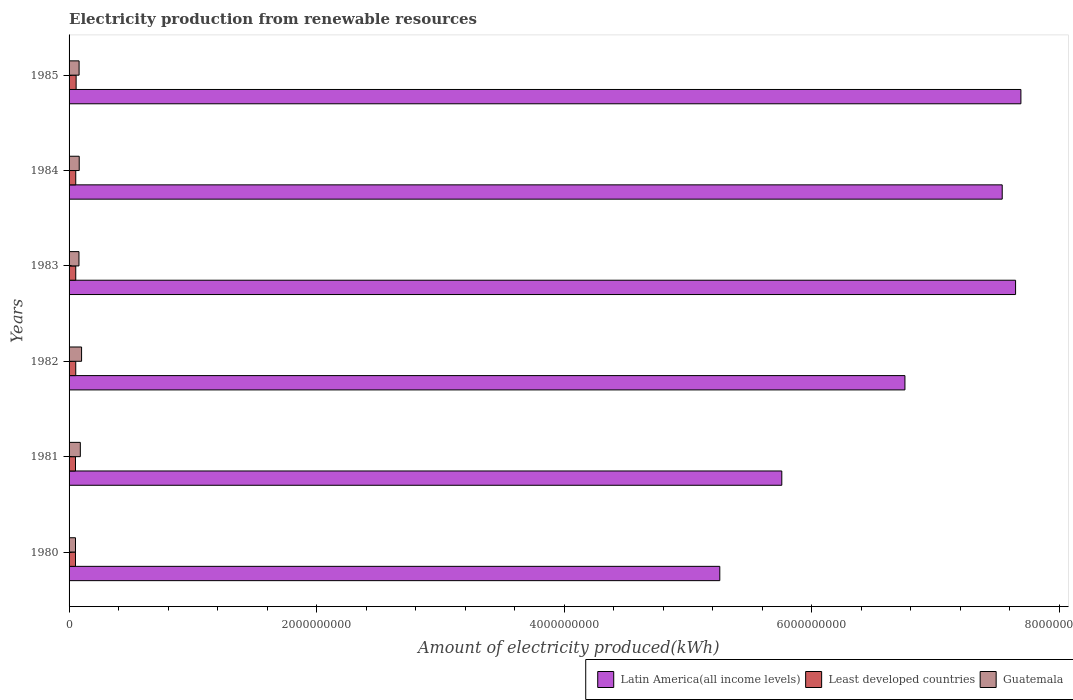How many groups of bars are there?
Your response must be concise. 6. Are the number of bars per tick equal to the number of legend labels?
Your answer should be compact. Yes. Are the number of bars on each tick of the Y-axis equal?
Your response must be concise. Yes. What is the amount of electricity produced in Guatemala in 1980?
Offer a very short reply. 5.20e+07. Across all years, what is the maximum amount of electricity produced in Latin America(all income levels)?
Provide a short and direct response. 7.69e+09. Across all years, what is the minimum amount of electricity produced in Least developed countries?
Your response must be concise. 5.20e+07. In which year was the amount of electricity produced in Guatemala maximum?
Ensure brevity in your answer.  1982. In which year was the amount of electricity produced in Latin America(all income levels) minimum?
Your answer should be compact. 1980. What is the total amount of electricity produced in Guatemala in the graph?
Offer a terse response. 4.87e+08. What is the difference between the amount of electricity produced in Latin America(all income levels) in 1982 and that in 1983?
Your answer should be very brief. -8.94e+08. What is the difference between the amount of electricity produced in Guatemala in 1983 and the amount of electricity produced in Latin America(all income levels) in 1984?
Offer a terse response. -7.46e+09. What is the average amount of electricity produced in Latin America(all income levels) per year?
Provide a short and direct response. 6.78e+09. What is the ratio of the amount of electricity produced in Latin America(all income levels) in 1980 to that in 1982?
Provide a short and direct response. 0.78. What is the difference between the highest and the second highest amount of electricity produced in Latin America(all income levels)?
Your answer should be very brief. 4.30e+07. What is the difference between the highest and the lowest amount of electricity produced in Least developed countries?
Offer a very short reply. 5.00e+06. In how many years, is the amount of electricity produced in Latin America(all income levels) greater than the average amount of electricity produced in Latin America(all income levels) taken over all years?
Give a very brief answer. 3. Is the sum of the amount of electricity produced in Guatemala in 1981 and 1984 greater than the maximum amount of electricity produced in Least developed countries across all years?
Your response must be concise. Yes. What does the 3rd bar from the top in 1982 represents?
Give a very brief answer. Latin America(all income levels). What does the 3rd bar from the bottom in 1985 represents?
Your response must be concise. Guatemala. Is it the case that in every year, the sum of the amount of electricity produced in Guatemala and amount of electricity produced in Latin America(all income levels) is greater than the amount of electricity produced in Least developed countries?
Provide a short and direct response. Yes. How many bars are there?
Ensure brevity in your answer.  18. Are all the bars in the graph horizontal?
Provide a short and direct response. Yes. What is the difference between two consecutive major ticks on the X-axis?
Your response must be concise. 2.00e+09. Are the values on the major ticks of X-axis written in scientific E-notation?
Offer a terse response. No. Where does the legend appear in the graph?
Ensure brevity in your answer.  Bottom right. How are the legend labels stacked?
Provide a succinct answer. Horizontal. What is the title of the graph?
Offer a very short reply. Electricity production from renewable resources. Does "Kazakhstan" appear as one of the legend labels in the graph?
Offer a very short reply. No. What is the label or title of the X-axis?
Provide a short and direct response. Amount of electricity produced(kWh). What is the label or title of the Y-axis?
Your response must be concise. Years. What is the Amount of electricity produced(kWh) in Latin America(all income levels) in 1980?
Your answer should be compact. 5.26e+09. What is the Amount of electricity produced(kWh) in Least developed countries in 1980?
Offer a very short reply. 5.20e+07. What is the Amount of electricity produced(kWh) of Guatemala in 1980?
Your answer should be compact. 5.20e+07. What is the Amount of electricity produced(kWh) of Latin America(all income levels) in 1981?
Keep it short and to the point. 5.76e+09. What is the Amount of electricity produced(kWh) of Least developed countries in 1981?
Give a very brief answer. 5.20e+07. What is the Amount of electricity produced(kWh) in Guatemala in 1981?
Provide a succinct answer. 9.10e+07. What is the Amount of electricity produced(kWh) of Latin America(all income levels) in 1982?
Your answer should be compact. 6.75e+09. What is the Amount of electricity produced(kWh) in Least developed countries in 1982?
Offer a very short reply. 5.40e+07. What is the Amount of electricity produced(kWh) of Guatemala in 1982?
Your response must be concise. 1.01e+08. What is the Amount of electricity produced(kWh) of Latin America(all income levels) in 1983?
Your answer should be compact. 7.65e+09. What is the Amount of electricity produced(kWh) in Least developed countries in 1983?
Offer a very short reply. 5.40e+07. What is the Amount of electricity produced(kWh) in Guatemala in 1983?
Give a very brief answer. 8.00e+07. What is the Amount of electricity produced(kWh) in Latin America(all income levels) in 1984?
Keep it short and to the point. 7.54e+09. What is the Amount of electricity produced(kWh) in Least developed countries in 1984?
Offer a very short reply. 5.40e+07. What is the Amount of electricity produced(kWh) of Guatemala in 1984?
Offer a terse response. 8.20e+07. What is the Amount of electricity produced(kWh) in Latin America(all income levels) in 1985?
Ensure brevity in your answer.  7.69e+09. What is the Amount of electricity produced(kWh) of Least developed countries in 1985?
Offer a terse response. 5.70e+07. What is the Amount of electricity produced(kWh) in Guatemala in 1985?
Give a very brief answer. 8.10e+07. Across all years, what is the maximum Amount of electricity produced(kWh) of Latin America(all income levels)?
Ensure brevity in your answer.  7.69e+09. Across all years, what is the maximum Amount of electricity produced(kWh) of Least developed countries?
Your answer should be very brief. 5.70e+07. Across all years, what is the maximum Amount of electricity produced(kWh) of Guatemala?
Give a very brief answer. 1.01e+08. Across all years, what is the minimum Amount of electricity produced(kWh) of Latin America(all income levels)?
Give a very brief answer. 5.26e+09. Across all years, what is the minimum Amount of electricity produced(kWh) in Least developed countries?
Make the answer very short. 5.20e+07. Across all years, what is the minimum Amount of electricity produced(kWh) of Guatemala?
Provide a short and direct response. 5.20e+07. What is the total Amount of electricity produced(kWh) in Latin America(all income levels) in the graph?
Provide a short and direct response. 4.06e+1. What is the total Amount of electricity produced(kWh) in Least developed countries in the graph?
Provide a succinct answer. 3.23e+08. What is the total Amount of electricity produced(kWh) of Guatemala in the graph?
Ensure brevity in your answer.  4.87e+08. What is the difference between the Amount of electricity produced(kWh) in Latin America(all income levels) in 1980 and that in 1981?
Provide a succinct answer. -5.01e+08. What is the difference between the Amount of electricity produced(kWh) in Least developed countries in 1980 and that in 1981?
Ensure brevity in your answer.  0. What is the difference between the Amount of electricity produced(kWh) in Guatemala in 1980 and that in 1981?
Make the answer very short. -3.90e+07. What is the difference between the Amount of electricity produced(kWh) in Latin America(all income levels) in 1980 and that in 1982?
Your response must be concise. -1.50e+09. What is the difference between the Amount of electricity produced(kWh) of Least developed countries in 1980 and that in 1982?
Your answer should be compact. -2.00e+06. What is the difference between the Amount of electricity produced(kWh) in Guatemala in 1980 and that in 1982?
Provide a short and direct response. -4.90e+07. What is the difference between the Amount of electricity produced(kWh) of Latin America(all income levels) in 1980 and that in 1983?
Keep it short and to the point. -2.39e+09. What is the difference between the Amount of electricity produced(kWh) in Guatemala in 1980 and that in 1983?
Make the answer very short. -2.80e+07. What is the difference between the Amount of electricity produced(kWh) of Latin America(all income levels) in 1980 and that in 1984?
Provide a succinct answer. -2.28e+09. What is the difference between the Amount of electricity produced(kWh) in Guatemala in 1980 and that in 1984?
Provide a succinct answer. -3.00e+07. What is the difference between the Amount of electricity produced(kWh) of Latin America(all income levels) in 1980 and that in 1985?
Make the answer very short. -2.43e+09. What is the difference between the Amount of electricity produced(kWh) of Least developed countries in 1980 and that in 1985?
Your response must be concise. -5.00e+06. What is the difference between the Amount of electricity produced(kWh) in Guatemala in 1980 and that in 1985?
Make the answer very short. -2.90e+07. What is the difference between the Amount of electricity produced(kWh) in Latin America(all income levels) in 1981 and that in 1982?
Your response must be concise. -9.95e+08. What is the difference between the Amount of electricity produced(kWh) in Least developed countries in 1981 and that in 1982?
Keep it short and to the point. -2.00e+06. What is the difference between the Amount of electricity produced(kWh) in Guatemala in 1981 and that in 1982?
Your answer should be very brief. -1.00e+07. What is the difference between the Amount of electricity produced(kWh) of Latin America(all income levels) in 1981 and that in 1983?
Keep it short and to the point. -1.89e+09. What is the difference between the Amount of electricity produced(kWh) in Least developed countries in 1981 and that in 1983?
Your answer should be compact. -2.00e+06. What is the difference between the Amount of electricity produced(kWh) in Guatemala in 1981 and that in 1983?
Ensure brevity in your answer.  1.10e+07. What is the difference between the Amount of electricity produced(kWh) in Latin America(all income levels) in 1981 and that in 1984?
Keep it short and to the point. -1.78e+09. What is the difference between the Amount of electricity produced(kWh) of Least developed countries in 1981 and that in 1984?
Your answer should be compact. -2.00e+06. What is the difference between the Amount of electricity produced(kWh) of Guatemala in 1981 and that in 1984?
Offer a very short reply. 9.00e+06. What is the difference between the Amount of electricity produced(kWh) of Latin America(all income levels) in 1981 and that in 1985?
Ensure brevity in your answer.  -1.93e+09. What is the difference between the Amount of electricity produced(kWh) of Least developed countries in 1981 and that in 1985?
Your response must be concise. -5.00e+06. What is the difference between the Amount of electricity produced(kWh) of Guatemala in 1981 and that in 1985?
Offer a very short reply. 1.00e+07. What is the difference between the Amount of electricity produced(kWh) of Latin America(all income levels) in 1982 and that in 1983?
Offer a terse response. -8.94e+08. What is the difference between the Amount of electricity produced(kWh) of Least developed countries in 1982 and that in 1983?
Keep it short and to the point. 0. What is the difference between the Amount of electricity produced(kWh) of Guatemala in 1982 and that in 1983?
Offer a very short reply. 2.10e+07. What is the difference between the Amount of electricity produced(kWh) in Latin America(all income levels) in 1982 and that in 1984?
Offer a terse response. -7.86e+08. What is the difference between the Amount of electricity produced(kWh) of Guatemala in 1982 and that in 1984?
Provide a succinct answer. 1.90e+07. What is the difference between the Amount of electricity produced(kWh) of Latin America(all income levels) in 1982 and that in 1985?
Keep it short and to the point. -9.37e+08. What is the difference between the Amount of electricity produced(kWh) in Least developed countries in 1982 and that in 1985?
Keep it short and to the point. -3.00e+06. What is the difference between the Amount of electricity produced(kWh) of Guatemala in 1982 and that in 1985?
Provide a short and direct response. 2.00e+07. What is the difference between the Amount of electricity produced(kWh) in Latin America(all income levels) in 1983 and that in 1984?
Your answer should be compact. 1.08e+08. What is the difference between the Amount of electricity produced(kWh) in Guatemala in 1983 and that in 1984?
Provide a succinct answer. -2.00e+06. What is the difference between the Amount of electricity produced(kWh) in Latin America(all income levels) in 1983 and that in 1985?
Provide a short and direct response. -4.30e+07. What is the difference between the Amount of electricity produced(kWh) in Guatemala in 1983 and that in 1985?
Keep it short and to the point. -1.00e+06. What is the difference between the Amount of electricity produced(kWh) of Latin America(all income levels) in 1984 and that in 1985?
Offer a terse response. -1.51e+08. What is the difference between the Amount of electricity produced(kWh) of Latin America(all income levels) in 1980 and the Amount of electricity produced(kWh) of Least developed countries in 1981?
Make the answer very short. 5.21e+09. What is the difference between the Amount of electricity produced(kWh) in Latin America(all income levels) in 1980 and the Amount of electricity produced(kWh) in Guatemala in 1981?
Ensure brevity in your answer.  5.17e+09. What is the difference between the Amount of electricity produced(kWh) in Least developed countries in 1980 and the Amount of electricity produced(kWh) in Guatemala in 1981?
Ensure brevity in your answer.  -3.90e+07. What is the difference between the Amount of electricity produced(kWh) in Latin America(all income levels) in 1980 and the Amount of electricity produced(kWh) in Least developed countries in 1982?
Offer a very short reply. 5.20e+09. What is the difference between the Amount of electricity produced(kWh) of Latin America(all income levels) in 1980 and the Amount of electricity produced(kWh) of Guatemala in 1982?
Your answer should be very brief. 5.16e+09. What is the difference between the Amount of electricity produced(kWh) of Least developed countries in 1980 and the Amount of electricity produced(kWh) of Guatemala in 1982?
Give a very brief answer. -4.90e+07. What is the difference between the Amount of electricity produced(kWh) of Latin America(all income levels) in 1980 and the Amount of electricity produced(kWh) of Least developed countries in 1983?
Give a very brief answer. 5.20e+09. What is the difference between the Amount of electricity produced(kWh) of Latin America(all income levels) in 1980 and the Amount of electricity produced(kWh) of Guatemala in 1983?
Make the answer very short. 5.18e+09. What is the difference between the Amount of electricity produced(kWh) of Least developed countries in 1980 and the Amount of electricity produced(kWh) of Guatemala in 1983?
Offer a very short reply. -2.80e+07. What is the difference between the Amount of electricity produced(kWh) of Latin America(all income levels) in 1980 and the Amount of electricity produced(kWh) of Least developed countries in 1984?
Offer a terse response. 5.20e+09. What is the difference between the Amount of electricity produced(kWh) in Latin America(all income levels) in 1980 and the Amount of electricity produced(kWh) in Guatemala in 1984?
Provide a succinct answer. 5.18e+09. What is the difference between the Amount of electricity produced(kWh) of Least developed countries in 1980 and the Amount of electricity produced(kWh) of Guatemala in 1984?
Your response must be concise. -3.00e+07. What is the difference between the Amount of electricity produced(kWh) of Latin America(all income levels) in 1980 and the Amount of electricity produced(kWh) of Least developed countries in 1985?
Offer a very short reply. 5.20e+09. What is the difference between the Amount of electricity produced(kWh) in Latin America(all income levels) in 1980 and the Amount of electricity produced(kWh) in Guatemala in 1985?
Provide a succinct answer. 5.18e+09. What is the difference between the Amount of electricity produced(kWh) in Least developed countries in 1980 and the Amount of electricity produced(kWh) in Guatemala in 1985?
Your answer should be compact. -2.90e+07. What is the difference between the Amount of electricity produced(kWh) of Latin America(all income levels) in 1981 and the Amount of electricity produced(kWh) of Least developed countries in 1982?
Provide a short and direct response. 5.70e+09. What is the difference between the Amount of electricity produced(kWh) in Latin America(all income levels) in 1981 and the Amount of electricity produced(kWh) in Guatemala in 1982?
Provide a succinct answer. 5.66e+09. What is the difference between the Amount of electricity produced(kWh) in Least developed countries in 1981 and the Amount of electricity produced(kWh) in Guatemala in 1982?
Make the answer very short. -4.90e+07. What is the difference between the Amount of electricity produced(kWh) in Latin America(all income levels) in 1981 and the Amount of electricity produced(kWh) in Least developed countries in 1983?
Your response must be concise. 5.70e+09. What is the difference between the Amount of electricity produced(kWh) of Latin America(all income levels) in 1981 and the Amount of electricity produced(kWh) of Guatemala in 1983?
Provide a short and direct response. 5.68e+09. What is the difference between the Amount of electricity produced(kWh) in Least developed countries in 1981 and the Amount of electricity produced(kWh) in Guatemala in 1983?
Your answer should be very brief. -2.80e+07. What is the difference between the Amount of electricity produced(kWh) in Latin America(all income levels) in 1981 and the Amount of electricity produced(kWh) in Least developed countries in 1984?
Provide a succinct answer. 5.70e+09. What is the difference between the Amount of electricity produced(kWh) in Latin America(all income levels) in 1981 and the Amount of electricity produced(kWh) in Guatemala in 1984?
Your answer should be compact. 5.68e+09. What is the difference between the Amount of electricity produced(kWh) in Least developed countries in 1981 and the Amount of electricity produced(kWh) in Guatemala in 1984?
Keep it short and to the point. -3.00e+07. What is the difference between the Amount of electricity produced(kWh) of Latin America(all income levels) in 1981 and the Amount of electricity produced(kWh) of Least developed countries in 1985?
Make the answer very short. 5.70e+09. What is the difference between the Amount of electricity produced(kWh) in Latin America(all income levels) in 1981 and the Amount of electricity produced(kWh) in Guatemala in 1985?
Your answer should be very brief. 5.68e+09. What is the difference between the Amount of electricity produced(kWh) in Least developed countries in 1981 and the Amount of electricity produced(kWh) in Guatemala in 1985?
Offer a very short reply. -2.90e+07. What is the difference between the Amount of electricity produced(kWh) in Latin America(all income levels) in 1982 and the Amount of electricity produced(kWh) in Least developed countries in 1983?
Ensure brevity in your answer.  6.70e+09. What is the difference between the Amount of electricity produced(kWh) in Latin America(all income levels) in 1982 and the Amount of electricity produced(kWh) in Guatemala in 1983?
Give a very brief answer. 6.67e+09. What is the difference between the Amount of electricity produced(kWh) of Least developed countries in 1982 and the Amount of electricity produced(kWh) of Guatemala in 1983?
Offer a very short reply. -2.60e+07. What is the difference between the Amount of electricity produced(kWh) in Latin America(all income levels) in 1982 and the Amount of electricity produced(kWh) in Least developed countries in 1984?
Make the answer very short. 6.70e+09. What is the difference between the Amount of electricity produced(kWh) in Latin America(all income levels) in 1982 and the Amount of electricity produced(kWh) in Guatemala in 1984?
Your response must be concise. 6.67e+09. What is the difference between the Amount of electricity produced(kWh) in Least developed countries in 1982 and the Amount of electricity produced(kWh) in Guatemala in 1984?
Make the answer very short. -2.80e+07. What is the difference between the Amount of electricity produced(kWh) in Latin America(all income levels) in 1982 and the Amount of electricity produced(kWh) in Least developed countries in 1985?
Your answer should be compact. 6.70e+09. What is the difference between the Amount of electricity produced(kWh) of Latin America(all income levels) in 1982 and the Amount of electricity produced(kWh) of Guatemala in 1985?
Give a very brief answer. 6.67e+09. What is the difference between the Amount of electricity produced(kWh) in Least developed countries in 1982 and the Amount of electricity produced(kWh) in Guatemala in 1985?
Keep it short and to the point. -2.70e+07. What is the difference between the Amount of electricity produced(kWh) in Latin America(all income levels) in 1983 and the Amount of electricity produced(kWh) in Least developed countries in 1984?
Your response must be concise. 7.59e+09. What is the difference between the Amount of electricity produced(kWh) of Latin America(all income levels) in 1983 and the Amount of electricity produced(kWh) of Guatemala in 1984?
Your response must be concise. 7.57e+09. What is the difference between the Amount of electricity produced(kWh) of Least developed countries in 1983 and the Amount of electricity produced(kWh) of Guatemala in 1984?
Provide a succinct answer. -2.80e+07. What is the difference between the Amount of electricity produced(kWh) in Latin America(all income levels) in 1983 and the Amount of electricity produced(kWh) in Least developed countries in 1985?
Your response must be concise. 7.59e+09. What is the difference between the Amount of electricity produced(kWh) of Latin America(all income levels) in 1983 and the Amount of electricity produced(kWh) of Guatemala in 1985?
Your response must be concise. 7.57e+09. What is the difference between the Amount of electricity produced(kWh) of Least developed countries in 1983 and the Amount of electricity produced(kWh) of Guatemala in 1985?
Give a very brief answer. -2.70e+07. What is the difference between the Amount of electricity produced(kWh) of Latin America(all income levels) in 1984 and the Amount of electricity produced(kWh) of Least developed countries in 1985?
Keep it short and to the point. 7.48e+09. What is the difference between the Amount of electricity produced(kWh) in Latin America(all income levels) in 1984 and the Amount of electricity produced(kWh) in Guatemala in 1985?
Offer a very short reply. 7.46e+09. What is the difference between the Amount of electricity produced(kWh) in Least developed countries in 1984 and the Amount of electricity produced(kWh) in Guatemala in 1985?
Offer a very short reply. -2.70e+07. What is the average Amount of electricity produced(kWh) of Latin America(all income levels) per year?
Provide a succinct answer. 6.78e+09. What is the average Amount of electricity produced(kWh) of Least developed countries per year?
Offer a terse response. 5.38e+07. What is the average Amount of electricity produced(kWh) of Guatemala per year?
Your response must be concise. 8.12e+07. In the year 1980, what is the difference between the Amount of electricity produced(kWh) in Latin America(all income levels) and Amount of electricity produced(kWh) in Least developed countries?
Your answer should be compact. 5.21e+09. In the year 1980, what is the difference between the Amount of electricity produced(kWh) in Latin America(all income levels) and Amount of electricity produced(kWh) in Guatemala?
Offer a terse response. 5.21e+09. In the year 1981, what is the difference between the Amount of electricity produced(kWh) of Latin America(all income levels) and Amount of electricity produced(kWh) of Least developed countries?
Provide a succinct answer. 5.71e+09. In the year 1981, what is the difference between the Amount of electricity produced(kWh) in Latin America(all income levels) and Amount of electricity produced(kWh) in Guatemala?
Your response must be concise. 5.67e+09. In the year 1981, what is the difference between the Amount of electricity produced(kWh) of Least developed countries and Amount of electricity produced(kWh) of Guatemala?
Offer a terse response. -3.90e+07. In the year 1982, what is the difference between the Amount of electricity produced(kWh) in Latin America(all income levels) and Amount of electricity produced(kWh) in Least developed countries?
Offer a very short reply. 6.70e+09. In the year 1982, what is the difference between the Amount of electricity produced(kWh) in Latin America(all income levels) and Amount of electricity produced(kWh) in Guatemala?
Your response must be concise. 6.65e+09. In the year 1982, what is the difference between the Amount of electricity produced(kWh) in Least developed countries and Amount of electricity produced(kWh) in Guatemala?
Your response must be concise. -4.70e+07. In the year 1983, what is the difference between the Amount of electricity produced(kWh) in Latin America(all income levels) and Amount of electricity produced(kWh) in Least developed countries?
Ensure brevity in your answer.  7.59e+09. In the year 1983, what is the difference between the Amount of electricity produced(kWh) in Latin America(all income levels) and Amount of electricity produced(kWh) in Guatemala?
Provide a succinct answer. 7.57e+09. In the year 1983, what is the difference between the Amount of electricity produced(kWh) in Least developed countries and Amount of electricity produced(kWh) in Guatemala?
Your answer should be very brief. -2.60e+07. In the year 1984, what is the difference between the Amount of electricity produced(kWh) in Latin America(all income levels) and Amount of electricity produced(kWh) in Least developed countries?
Offer a terse response. 7.49e+09. In the year 1984, what is the difference between the Amount of electricity produced(kWh) of Latin America(all income levels) and Amount of electricity produced(kWh) of Guatemala?
Your answer should be compact. 7.46e+09. In the year 1984, what is the difference between the Amount of electricity produced(kWh) in Least developed countries and Amount of electricity produced(kWh) in Guatemala?
Offer a very short reply. -2.80e+07. In the year 1985, what is the difference between the Amount of electricity produced(kWh) in Latin America(all income levels) and Amount of electricity produced(kWh) in Least developed countries?
Provide a succinct answer. 7.63e+09. In the year 1985, what is the difference between the Amount of electricity produced(kWh) in Latin America(all income levels) and Amount of electricity produced(kWh) in Guatemala?
Your answer should be compact. 7.61e+09. In the year 1985, what is the difference between the Amount of electricity produced(kWh) of Least developed countries and Amount of electricity produced(kWh) of Guatemala?
Your response must be concise. -2.40e+07. What is the ratio of the Amount of electricity produced(kWh) in Least developed countries in 1980 to that in 1981?
Ensure brevity in your answer.  1. What is the ratio of the Amount of electricity produced(kWh) in Guatemala in 1980 to that in 1981?
Give a very brief answer. 0.57. What is the ratio of the Amount of electricity produced(kWh) of Latin America(all income levels) in 1980 to that in 1982?
Offer a very short reply. 0.78. What is the ratio of the Amount of electricity produced(kWh) in Guatemala in 1980 to that in 1982?
Provide a succinct answer. 0.51. What is the ratio of the Amount of electricity produced(kWh) in Latin America(all income levels) in 1980 to that in 1983?
Offer a very short reply. 0.69. What is the ratio of the Amount of electricity produced(kWh) in Least developed countries in 1980 to that in 1983?
Your response must be concise. 0.96. What is the ratio of the Amount of electricity produced(kWh) of Guatemala in 1980 to that in 1983?
Give a very brief answer. 0.65. What is the ratio of the Amount of electricity produced(kWh) in Latin America(all income levels) in 1980 to that in 1984?
Provide a succinct answer. 0.7. What is the ratio of the Amount of electricity produced(kWh) of Least developed countries in 1980 to that in 1984?
Offer a very short reply. 0.96. What is the ratio of the Amount of electricity produced(kWh) in Guatemala in 1980 to that in 1984?
Keep it short and to the point. 0.63. What is the ratio of the Amount of electricity produced(kWh) of Latin America(all income levels) in 1980 to that in 1985?
Your answer should be very brief. 0.68. What is the ratio of the Amount of electricity produced(kWh) of Least developed countries in 1980 to that in 1985?
Ensure brevity in your answer.  0.91. What is the ratio of the Amount of electricity produced(kWh) in Guatemala in 1980 to that in 1985?
Offer a very short reply. 0.64. What is the ratio of the Amount of electricity produced(kWh) in Latin America(all income levels) in 1981 to that in 1982?
Your response must be concise. 0.85. What is the ratio of the Amount of electricity produced(kWh) in Guatemala in 1981 to that in 1982?
Offer a terse response. 0.9. What is the ratio of the Amount of electricity produced(kWh) in Latin America(all income levels) in 1981 to that in 1983?
Provide a short and direct response. 0.75. What is the ratio of the Amount of electricity produced(kWh) of Least developed countries in 1981 to that in 1983?
Offer a very short reply. 0.96. What is the ratio of the Amount of electricity produced(kWh) of Guatemala in 1981 to that in 1983?
Make the answer very short. 1.14. What is the ratio of the Amount of electricity produced(kWh) in Latin America(all income levels) in 1981 to that in 1984?
Your answer should be very brief. 0.76. What is the ratio of the Amount of electricity produced(kWh) in Least developed countries in 1981 to that in 1984?
Your response must be concise. 0.96. What is the ratio of the Amount of electricity produced(kWh) in Guatemala in 1981 to that in 1984?
Provide a succinct answer. 1.11. What is the ratio of the Amount of electricity produced(kWh) in Latin America(all income levels) in 1981 to that in 1985?
Ensure brevity in your answer.  0.75. What is the ratio of the Amount of electricity produced(kWh) of Least developed countries in 1981 to that in 1985?
Make the answer very short. 0.91. What is the ratio of the Amount of electricity produced(kWh) of Guatemala in 1981 to that in 1985?
Provide a short and direct response. 1.12. What is the ratio of the Amount of electricity produced(kWh) of Latin America(all income levels) in 1982 to that in 1983?
Offer a terse response. 0.88. What is the ratio of the Amount of electricity produced(kWh) in Guatemala in 1982 to that in 1983?
Offer a very short reply. 1.26. What is the ratio of the Amount of electricity produced(kWh) of Latin America(all income levels) in 1982 to that in 1984?
Offer a terse response. 0.9. What is the ratio of the Amount of electricity produced(kWh) of Least developed countries in 1982 to that in 1984?
Offer a terse response. 1. What is the ratio of the Amount of electricity produced(kWh) in Guatemala in 1982 to that in 1984?
Your response must be concise. 1.23. What is the ratio of the Amount of electricity produced(kWh) of Latin America(all income levels) in 1982 to that in 1985?
Provide a succinct answer. 0.88. What is the ratio of the Amount of electricity produced(kWh) in Least developed countries in 1982 to that in 1985?
Offer a very short reply. 0.95. What is the ratio of the Amount of electricity produced(kWh) of Guatemala in 1982 to that in 1985?
Offer a very short reply. 1.25. What is the ratio of the Amount of electricity produced(kWh) in Latin America(all income levels) in 1983 to that in 1984?
Make the answer very short. 1.01. What is the ratio of the Amount of electricity produced(kWh) of Least developed countries in 1983 to that in 1984?
Give a very brief answer. 1. What is the ratio of the Amount of electricity produced(kWh) of Guatemala in 1983 to that in 1984?
Make the answer very short. 0.98. What is the ratio of the Amount of electricity produced(kWh) in Least developed countries in 1983 to that in 1985?
Offer a terse response. 0.95. What is the ratio of the Amount of electricity produced(kWh) in Latin America(all income levels) in 1984 to that in 1985?
Your answer should be very brief. 0.98. What is the ratio of the Amount of electricity produced(kWh) in Guatemala in 1984 to that in 1985?
Offer a very short reply. 1.01. What is the difference between the highest and the second highest Amount of electricity produced(kWh) of Latin America(all income levels)?
Your answer should be very brief. 4.30e+07. What is the difference between the highest and the second highest Amount of electricity produced(kWh) of Least developed countries?
Your answer should be compact. 3.00e+06. What is the difference between the highest and the second highest Amount of electricity produced(kWh) in Guatemala?
Keep it short and to the point. 1.00e+07. What is the difference between the highest and the lowest Amount of electricity produced(kWh) in Latin America(all income levels)?
Ensure brevity in your answer.  2.43e+09. What is the difference between the highest and the lowest Amount of electricity produced(kWh) in Guatemala?
Provide a short and direct response. 4.90e+07. 